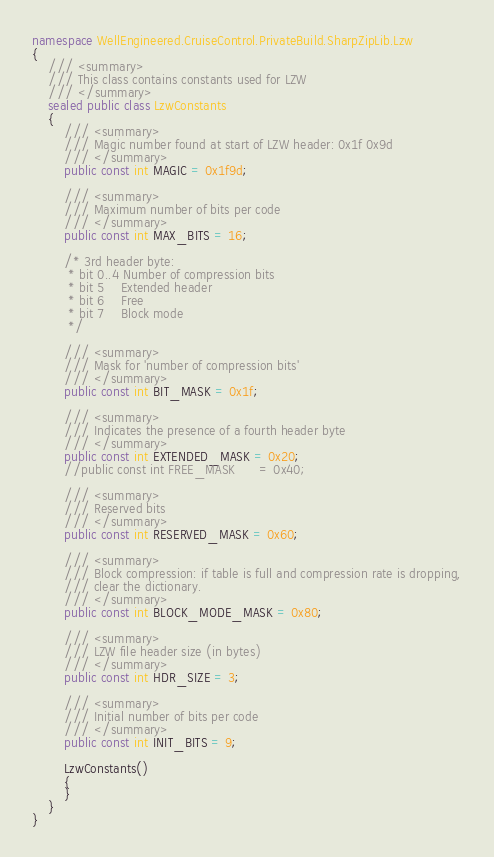<code> <loc_0><loc_0><loc_500><loc_500><_C#_>namespace WellEngineered.CruiseControl.PrivateBuild.SharpZipLib.Lzw
{
	/// <summary>
	/// This class contains constants used for LZW
	/// </summary>
	sealed public class LzwConstants
	{
		/// <summary>
		/// Magic number found at start of LZW header: 0x1f 0x9d
		/// </summary>
		public const int MAGIC = 0x1f9d;

		/// <summary>
		/// Maximum number of bits per code
		/// </summary>
		public const int MAX_BITS = 16;

		/* 3rd header byte:
         * bit 0..4 Number of compression bits
         * bit 5    Extended header
         * bit 6    Free
         * bit 7    Block mode
         */

		/// <summary>
		/// Mask for 'number of compression bits'
		/// </summary>
		public const int BIT_MASK = 0x1f;

		/// <summary>
		/// Indicates the presence of a fourth header byte
		/// </summary>
		public const int EXTENDED_MASK = 0x20;
		//public const int FREE_MASK      = 0x40;

		/// <summary>
		/// Reserved bits
		/// </summary>
		public const int RESERVED_MASK = 0x60;

		/// <summary>
		/// Block compression: if table is full and compression rate is dropping,
		/// clear the dictionary.
		/// </summary>
		public const int BLOCK_MODE_MASK = 0x80;

		/// <summary>
		/// LZW file header size (in bytes)
		/// </summary>
		public const int HDR_SIZE = 3;

		/// <summary>
		/// Initial number of bits per code
		/// </summary>
		public const int INIT_BITS = 9;

		LzwConstants()
		{
		}
	}
}
</code> 